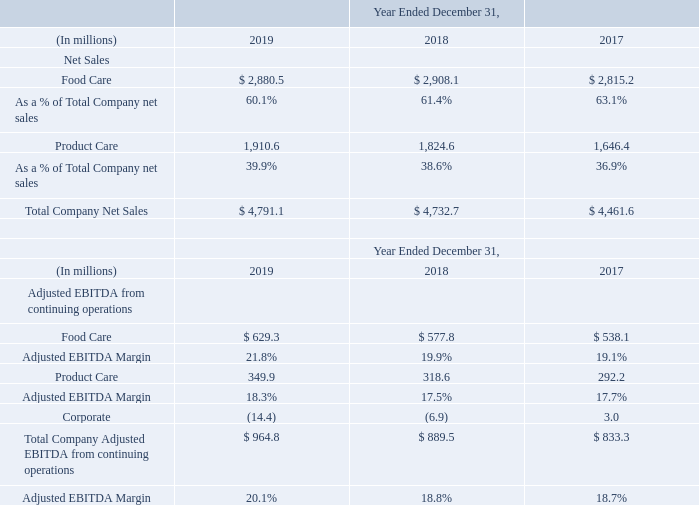Note 6 Segments
The Company’s segment reporting structure consists of two reportable segments and a Corporate category as follows: • Food Care; and • Product Care.
The Company’s Food Care and Product Care segments are considered reportable segments under FASB ASC Topic 280. Our reportable segments are aligned with similar groups of products. Corporate includes certain costs that are not allocated to or monitored by the reportable segments' management. The Company evaluates performance of the reportable segments based on the results of each segment. The performance metric used by the Company's chief operating decision maker to evaluate performance of our reportable segments is Adjusted EBITDA. The Company allocates expense to each segment based on various factors including direct usage of resources, allocation of headcount, allocation of software licenses or, in cases where costs are not clearly delineated, costs may be allocated on portion of either net trade sales or an expense factor such as cost of goods sold.
We allocate and disclose depreciation and amortization expense to our segments, although depreciation and amortization are not included in the segment performance metric Adjusted EBITDA. We also allocate and disclose restructuring charges and impairment of goodwill and other intangible assets by segment. However, restructuring charges and goodwill are not included in the segment performance metric Adjusted EBITDA since they are categorized as certain specified items (“Special Items”), in addition to certain transaction and other charges and gains related to acquisitions and divestitures and certain other specific items excluded from the calculation of Adjusted EBITDA. The accounting policies of the reportable segments and Corporate are the same as those applied to the Consolidated Financial Statements.
The following tables show Net Sales and Adjusted EBITDA by reportable segment:
What are the two reportable segments of the company? Food care, product care. What do the tables show? The following tables show net sales and adjusted ebitda by reportable segment. What is the Adjusted EBITDA Margin for year 2019 for the whole company? 20.1%. What is the average EBITDA Margin for years 2017-2019 for the whole company?
Answer scale should be: percent. (20.1+18.8+18.7)/3
Answer: 19.2. What is the percentage change of  Total Company Net Sales from year 2018 to year 2019?
Answer scale should be: percent. (4,791.1-4,732.7)/4,732.7
Answer: 1.23. What is the difference between the growth rate of net sales of Food care as compared to product care from 2017 to 2019?
Answer scale should be: percent. (2,880.5-2,815.2)/2,815.2-(1,910.6-1,646.4)/1,646.4
Answer: -13.73. What are the respective net sales for two reportable segments of the company in 2019?
Answer scale should be: million. 2,880.5, 1,910.6. 